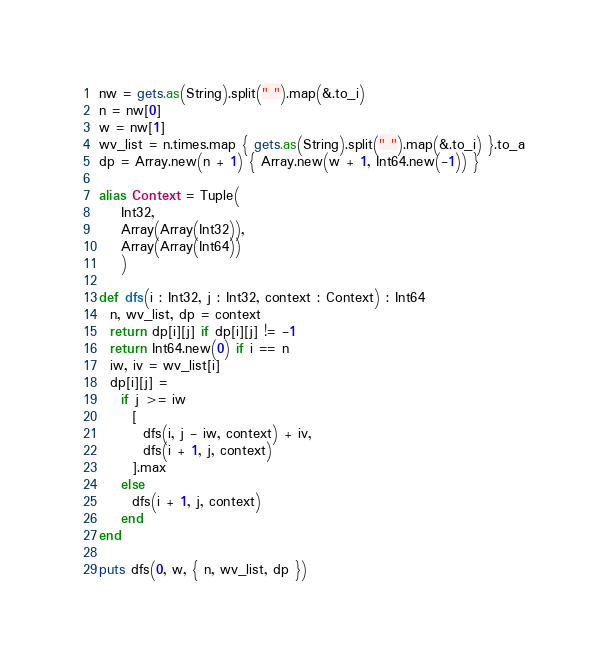<code> <loc_0><loc_0><loc_500><loc_500><_Crystal_>nw = gets.as(String).split(" ").map(&.to_i)
n = nw[0]
w = nw[1]
wv_list = n.times.map { gets.as(String).split(" ").map(&.to_i) }.to_a
dp = Array.new(n + 1) { Array.new(w + 1, Int64.new(-1)) }

alias Context = Tuple(
    Int32,
    Array(Array(Int32)),
    Array(Array(Int64))
    )

def dfs(i : Int32, j : Int32, context : Context) : Int64
  n, wv_list, dp = context
  return dp[i][j] if dp[i][j] != -1
  return Int64.new(0) if i == n
  iw, iv = wv_list[i]
  dp[i][j] =
    if j >= iw
      [
        dfs(i, j - iw, context) + iv,
        dfs(i + 1, j, context)
      ].max
    else
      dfs(i + 1, j, context)
    end
end

puts dfs(0, w, { n, wv_list, dp })</code> 